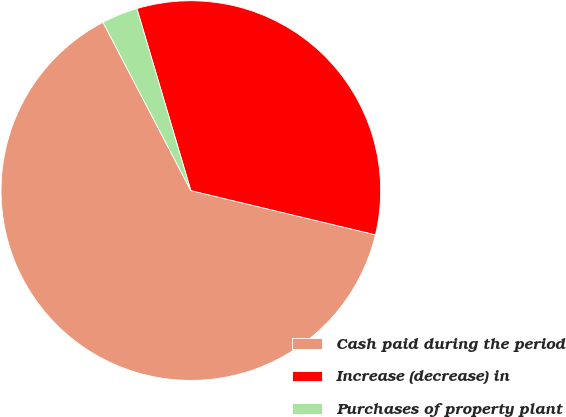<chart> <loc_0><loc_0><loc_500><loc_500><pie_chart><fcel>Cash paid during the period<fcel>Increase (decrease) in<fcel>Purchases of property plant<nl><fcel>63.6%<fcel>33.33%<fcel>3.07%<nl></chart> 